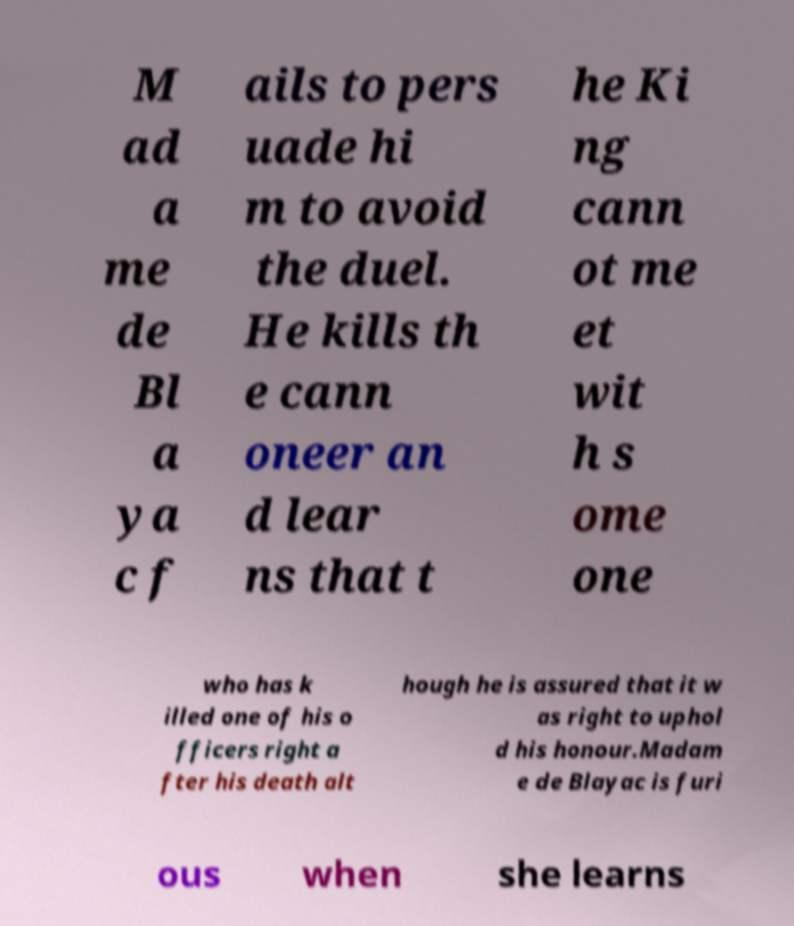Please read and relay the text visible in this image. What does it say? M ad a me de Bl a ya c f ails to pers uade hi m to avoid the duel. He kills th e cann oneer an d lear ns that t he Ki ng cann ot me et wit h s ome one who has k illed one of his o fficers right a fter his death alt hough he is assured that it w as right to uphol d his honour.Madam e de Blayac is furi ous when she learns 